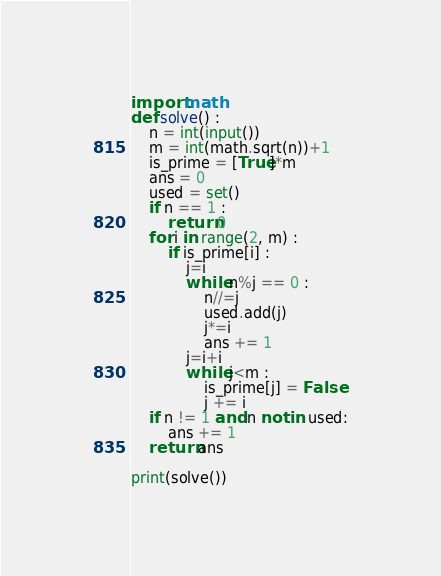Convert code to text. <code><loc_0><loc_0><loc_500><loc_500><_Python_>import math
def solve() :
    n = int(input())
    m = int(math.sqrt(n))+1
    is_prime = [True]*m
    ans = 0
    used = set()
    if n == 1 :
        return 0
    for i in range(2, m) :
        if is_prime[i] :
            j=i 
            while n%j == 0 :
                n//=j 
                used.add(j)
                j*=i
                ans += 1
            j=i+i 
            while j<m :
                is_prime[j] = False
                j += i 
    if n != 1 and n not in used:
        ans += 1
    return ans

print(solve())</code> 